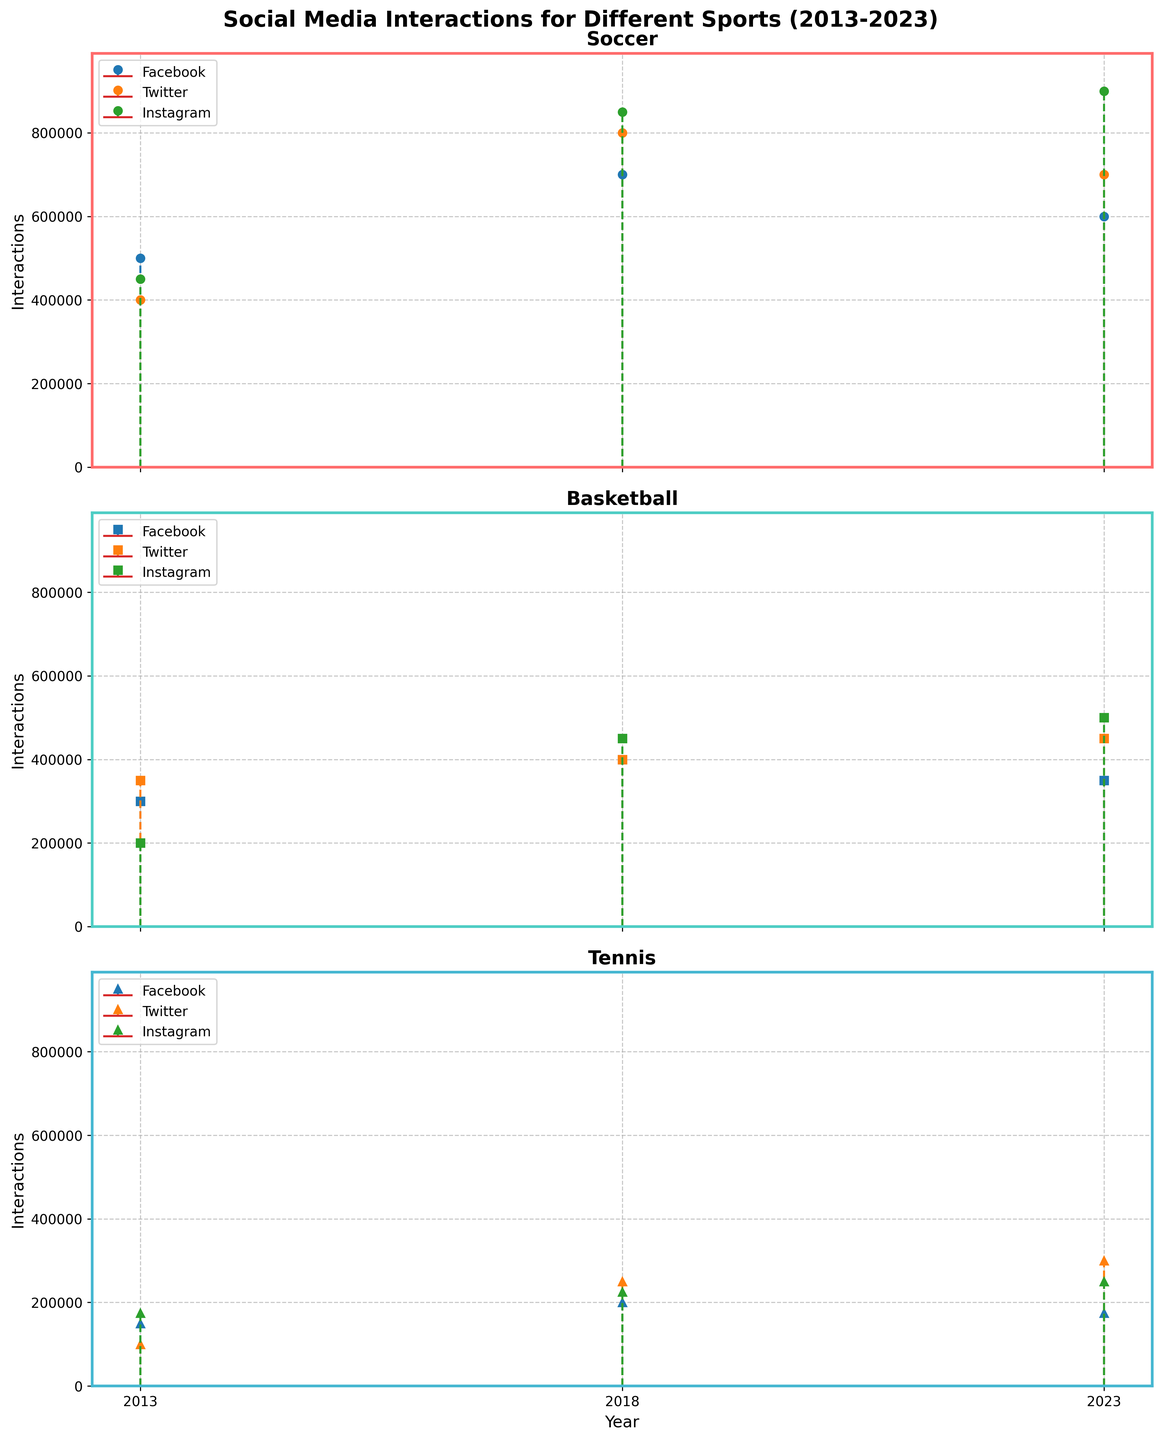What's the title of the figure? The title of the figure is displayed at the top, reading 'Social Media Interactions for Different Sports (2013-2023).'
Answer: Social Media Interactions for Different Sports (2013-2023) How many different sports are represented in the figure? We can see three separate subplots, each titled with a different sport: 'Soccer,' 'Basketball,' and 'Tennis.'
Answer: Three Which social media platform had the highest interactions for Soccer in 2023? In the Soccer subplot, the highest stem plot for 2023 reaches 900,000 interactions, which is marked for Instagram.
Answer: Instagram How did Facebook interactions for Basketball change from 2013 to 2023? Checking the stem heights in the Basketball subplot for Facebook, they went from 300,000 in 2013 to 350,000 in 2023, showing an increase.
Answer: Increased Comparing Twitter interactions, which sport had the biggest increase in interactions from 2013 to 2023? Checking the Twitter interactions in each subplot: Soccer went from 400,000 to 700,000 (300,000 increase), Basketball from 350,000 to 450,000 (100,000 increase), and Tennis from 100,000 to 300,000 (200,000 increase). The biggest increase is for Soccer.
Answer: Soccer Which sport had the most consistent Facebook interactions across the years? Soccer's Facebook interactions are 500,000 (2013), 700,000 (2018), and 600,000 (2023), showing variability. Basketball's are 300,000, 400,000, and, 350,000 showing some variability. Tennis’ interactions are 150,000, 200,000, and 175,000, which also show some variability. Soccer is relatively more consistent compared to others.
Answer: Soccer What is the highest number of interactions recorded for Tennis and which platform was it on? In the Tennis subplot, the highest stem height is for Twitter in 2023, reaching 300,000 interactions.
Answer: Twitter, 300,000 What is the overall trend in Instagram interactions for Soccer from 2013 to 2023? In the Soccer subplot, Instagram interactions show an increasing trend, with 450,000 in 2013, 850,000 in 2018, and 900,000 in 2023.
Answer: Increasing Which platform saw a decrease in interactions for Soccer from 2018 to 2023? Examining the interactions for Soccer subplot, Facebook interactions decreased from 700,000 in 2018 to 600,000 in 2023.
Answer: Facebook 